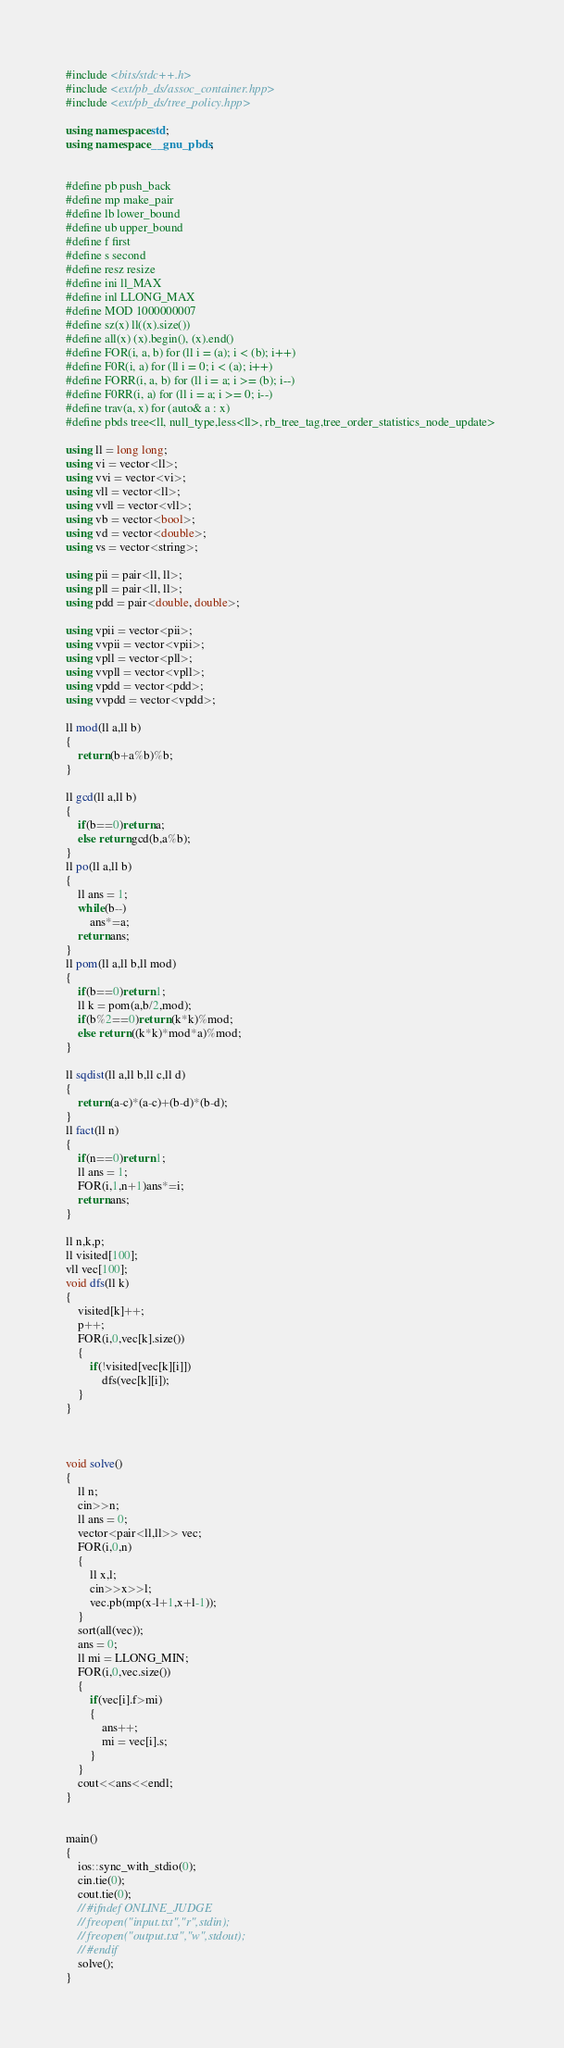Convert code to text. <code><loc_0><loc_0><loc_500><loc_500><_C++_>#include <bits/stdc++.h>
#include <ext/pb_ds/assoc_container.hpp> 
#include <ext/pb_ds/tree_policy.hpp> 
     
using namespace std;
using namespace __gnu_pbds;
     
     
#define pb push_back
#define mp make_pair
#define lb lower_bound
#define ub upper_bound
#define f first
#define s second
#define resz resize
#define ini ll_MAX
#define inl LLONG_MAX
#define MOD 1000000007
#define sz(x) ll((x).size())
#define all(x) (x).begin(), (x).end()
#define FOR(i, a, b) for (ll i = (a); i < (b); i++)
#define F0R(i, a) for (ll i = 0; i < (a); i++)
#define FORR(i, a, b) for (ll i = a; i >= (b); i--)
#define F0RR(i, a) for (ll i = a; i >= 0; i--)
#define trav(a, x) for (auto& a : x)
#define pbds tree<ll, null_type,less<ll>, rb_tree_tag,tree_order_statistics_node_update> 
     
using ll = long long;
using vi = vector<ll>;
using vvi = vector<vi>;
using vll = vector<ll>;
using vvll = vector<vll>;
using vb = vector<bool>;
using vd = vector<double>;
using vs = vector<string>;
     
using pii = pair<ll, ll>;
using pll = pair<ll, ll>;
using pdd = pair<double, double>;
     
using vpii = vector<pii>;
using vvpii = vector<vpii>;
using vpll = vector<pll>;
using vvpll = vector<vpll>;
using vpdd = vector<pdd>;
using vvpdd = vector<vpdd>;
     
ll mod(ll a,ll b)
{
    return (b+a%b)%b;
}
     
ll gcd(ll a,ll b)
{
    if(b==0)return a;
    else return gcd(b,a%b);
}
ll po(ll a,ll b)
{
    ll ans = 1;
    while(b--)
        ans*=a;
    return ans;
}
ll pom(ll a,ll b,ll mod)
{
    if(b==0)return 1;
    ll k = pom(a,b/2,mod);
    if(b%2==0)return (k*k)%mod;
    else return ((k*k)*mod*a)%mod;
}
     
ll sqdist(ll a,ll b,ll c,ll d)
{
    return (a-c)*(a-c)+(b-d)*(b-d);
}
ll fact(ll n)
{
    if(n==0)return 1;
    ll ans = 1;
    FOR(i,1,n+1)ans*=i;
    return ans;
}

ll n,k,p;
ll visited[100];
vll vec[100];
void dfs(ll k)
{
    visited[k]++;
    p++;
    FOR(i,0,vec[k].size())
    {
        if(!visited[vec[k][i]])
            dfs(vec[k][i]);
    }
}


     
void solve()
{
    ll n;
    cin>>n;
    ll ans = 0;
    vector<pair<ll,ll>> vec;
    FOR(i,0,n)
    {
        ll x,l;
        cin>>x>>l;
        vec.pb(mp(x-l+1,x+l-1));
    }
    sort(all(vec));
    ans = 0;
    ll mi = LLONG_MIN;
    FOR(i,0,vec.size())
    {
        if(vec[i].f>mi)
        {
            ans++;
            mi = vec[i].s;
        }
    }
    cout<<ans<<endl;
}
     
     
main()
{
    ios::sync_with_stdio(0);
    cin.tie(0);
    cout.tie(0);
    // #ifndef ONLINE_JUDGE
    // freopen("input.txt","r",stdin);
    // freopen("output.txt","w",stdout);
    // #endif
    solve();
}</code> 